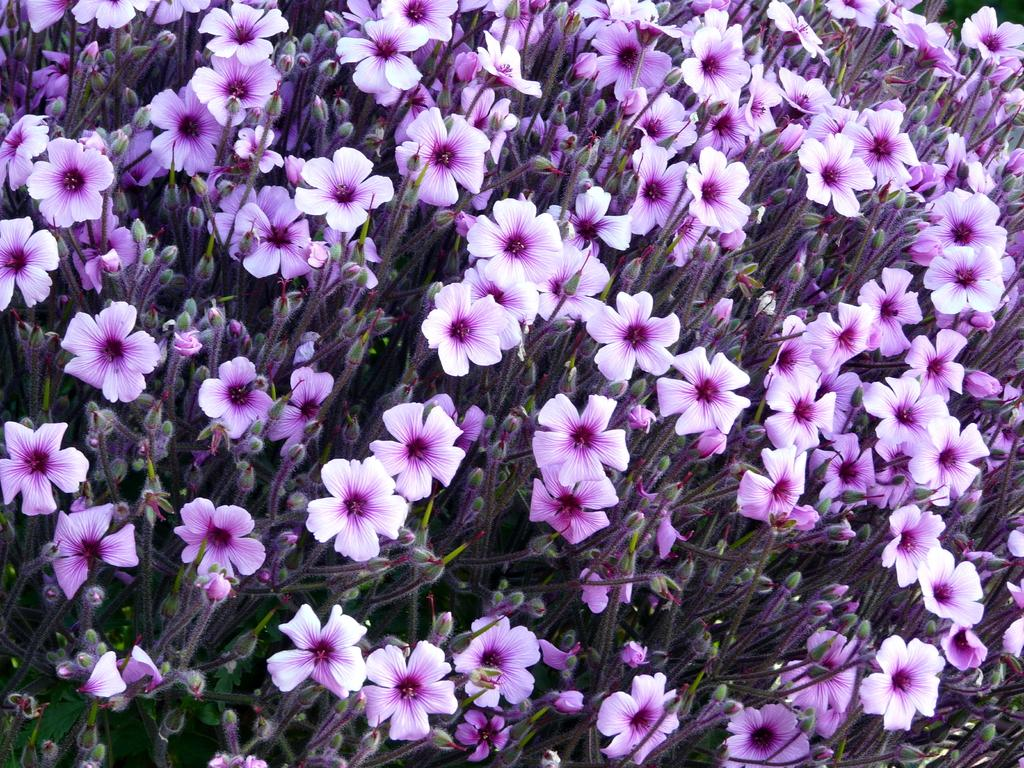What type of living organisms are present in the image? There is a group of plants in the image. What specific features can be observed on the plants? The plants have flowers and buds. What word does the expert use to describe the ear in the image? There is no expert or ear present in the image; it features a group of plants with flowers and buds. 